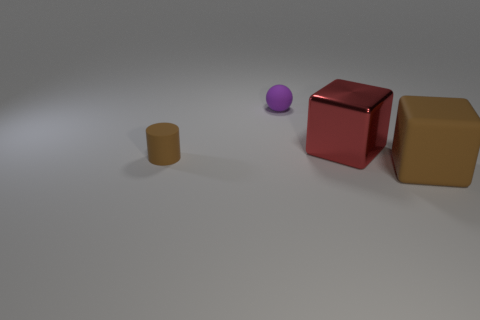Add 3 tiny matte cylinders. How many objects exist? 7 Subtract all balls. How many objects are left? 3 Add 3 big metallic things. How many big metallic things are left? 4 Add 4 tiny brown cylinders. How many tiny brown cylinders exist? 5 Subtract 0 yellow cylinders. How many objects are left? 4 Subtract all big things. Subtract all big cyan matte cylinders. How many objects are left? 2 